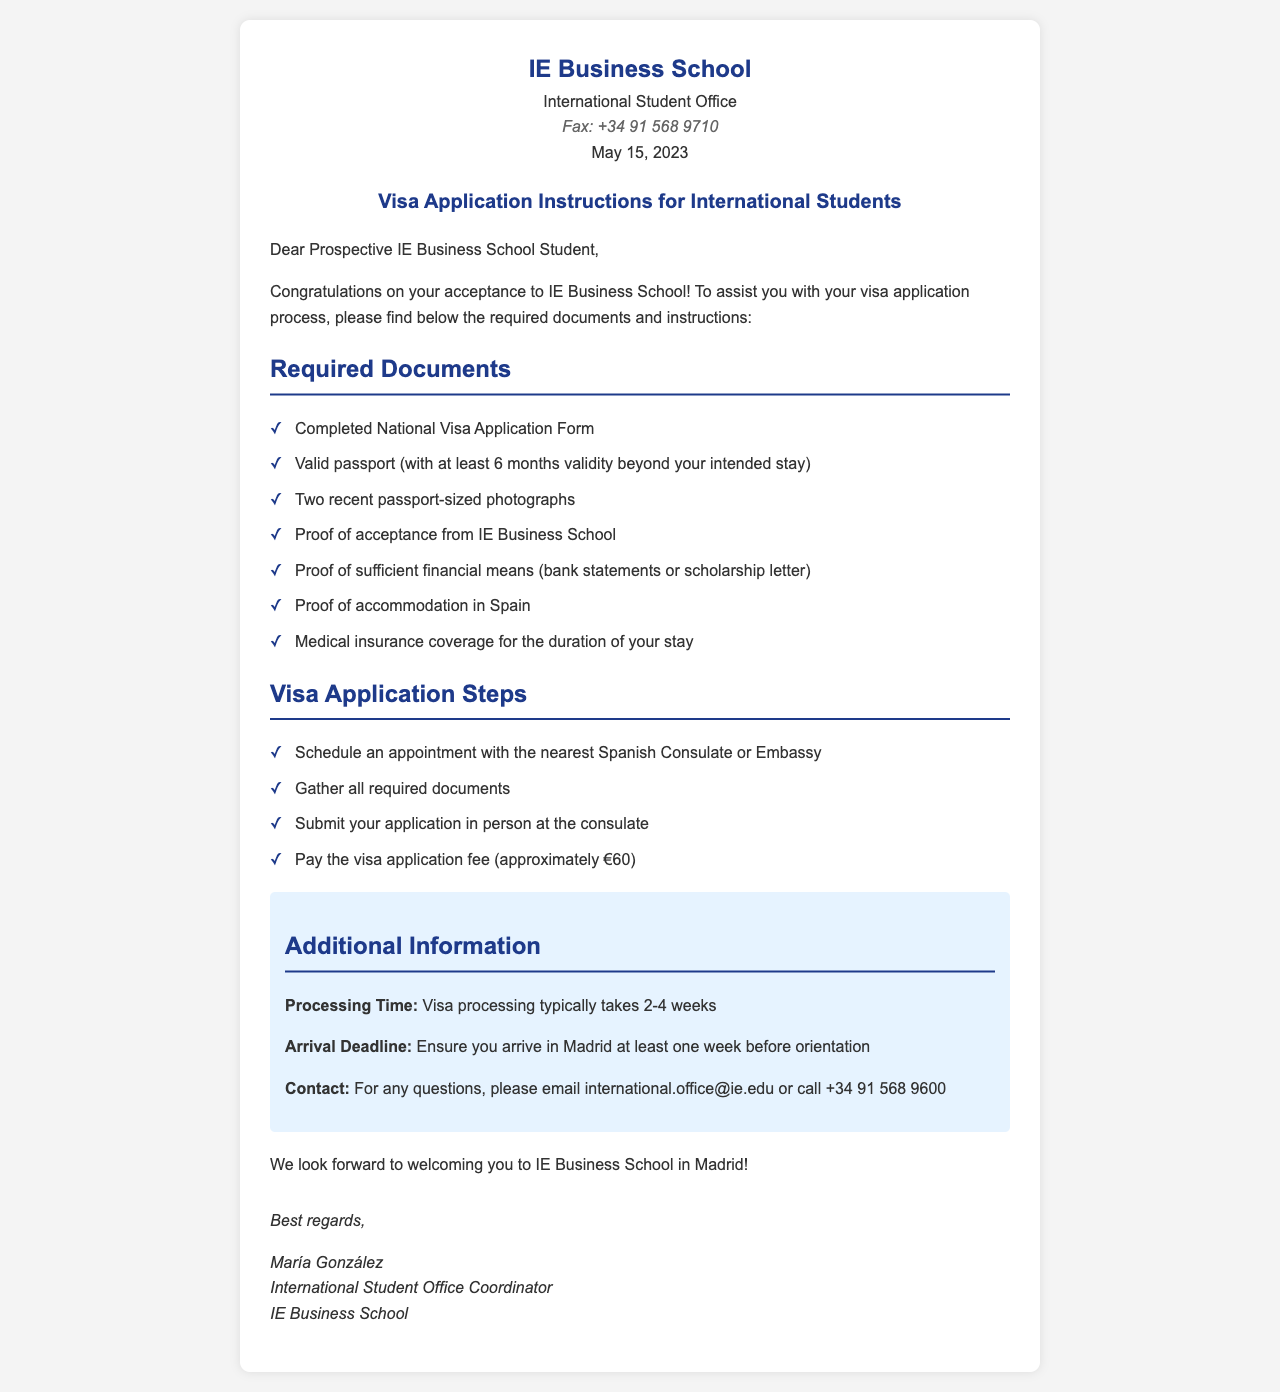what is the date on the fax? The date on the fax is mentioned in the header as May 15, 2023.
Answer: May 15, 2023 who is the coordinator of the International Student Office? The fax includes the name of the coordinator at the bottom, identifying María González as the coordinator.
Answer: María González how much is the visa application fee? The document states that the visa application fee is approximately €60.
Answer: approximately €60 how long does visa processing take? The additional information section specifies that visa processing typically takes 2-4 weeks.
Answer: 2-4 weeks what proof is required for accommodation? The required documents list includes "Proof of accommodation in Spain".
Answer: Proof of accommodation in Spain what is the first step for the visa application? The steps section indicates that the first step is to "Schedule an appointment with the nearest Spanish Consulate or Embassy".
Answer: Schedule an appointment with the nearest Spanish Consulate or Embassy how can you contact the International Student Office? The additional information section provides contact details, suggesting to use email international.office@ie.edu or call +34 91 568 9600.
Answer: international.office@ie.edu or call +34 91 568 9600 what type of insurance is required? The required documents list specifically requests "Medical insurance coverage for the duration of your stay".
Answer: Medical insurance coverage for the duration of your stay 